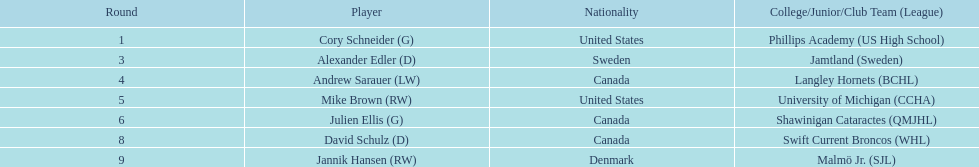How many participants were from the united states? 2. Help me parse the entirety of this table. {'header': ['Round', 'Player', 'Nationality', 'College/Junior/Club Team (League)'], 'rows': [['1', 'Cory Schneider (G)', 'United States', 'Phillips Academy (US High School)'], ['3', 'Alexander Edler (D)', 'Sweden', 'Jamtland (Sweden)'], ['4', 'Andrew Sarauer (LW)', 'Canada', 'Langley Hornets (BCHL)'], ['5', 'Mike Brown (RW)', 'United States', 'University of Michigan (CCHA)'], ['6', 'Julien Ellis (G)', 'Canada', 'Shawinigan Cataractes (QMJHL)'], ['8', 'David Schulz (D)', 'Canada', 'Swift Current Broncos (WHL)'], ['9', 'Jannik Hansen (RW)', 'Denmark', 'Malmö Jr. (SJL)']]} 